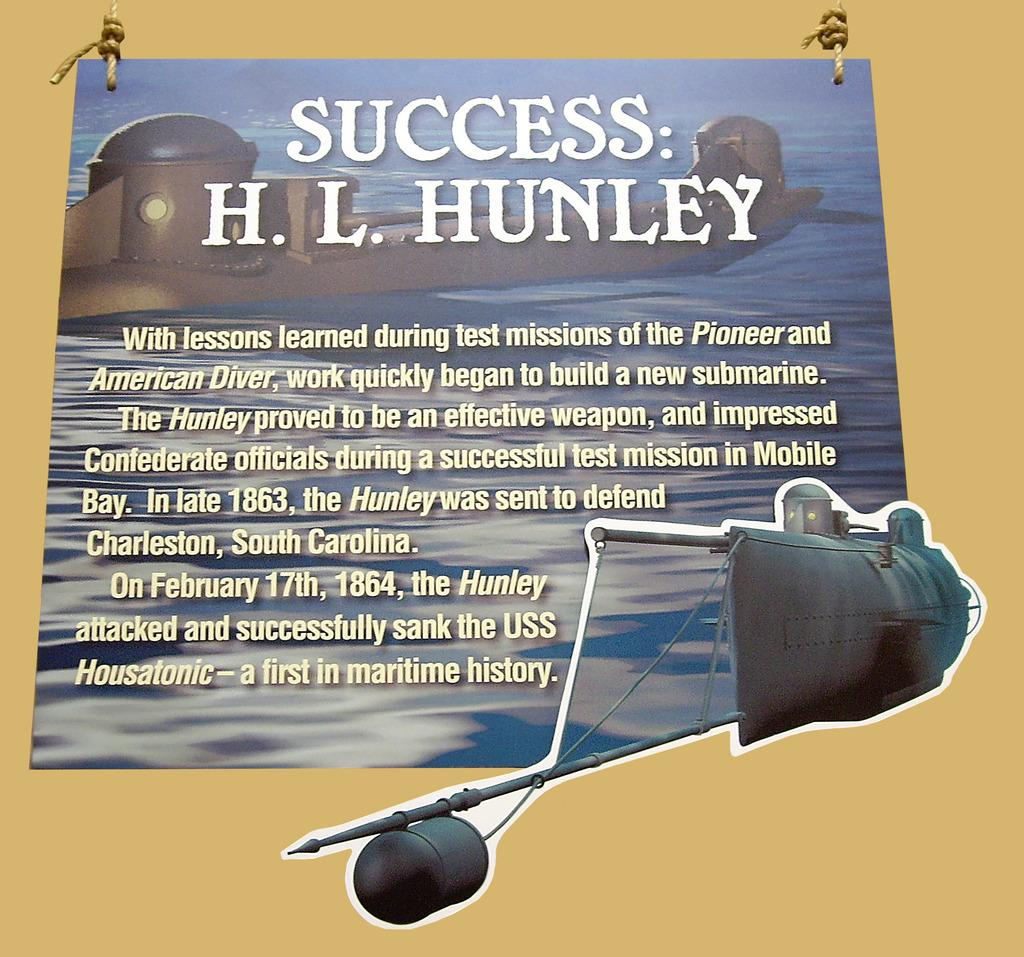<image>
Summarize the visual content of the image. A poster describes the story of the H.L. Hunley. 